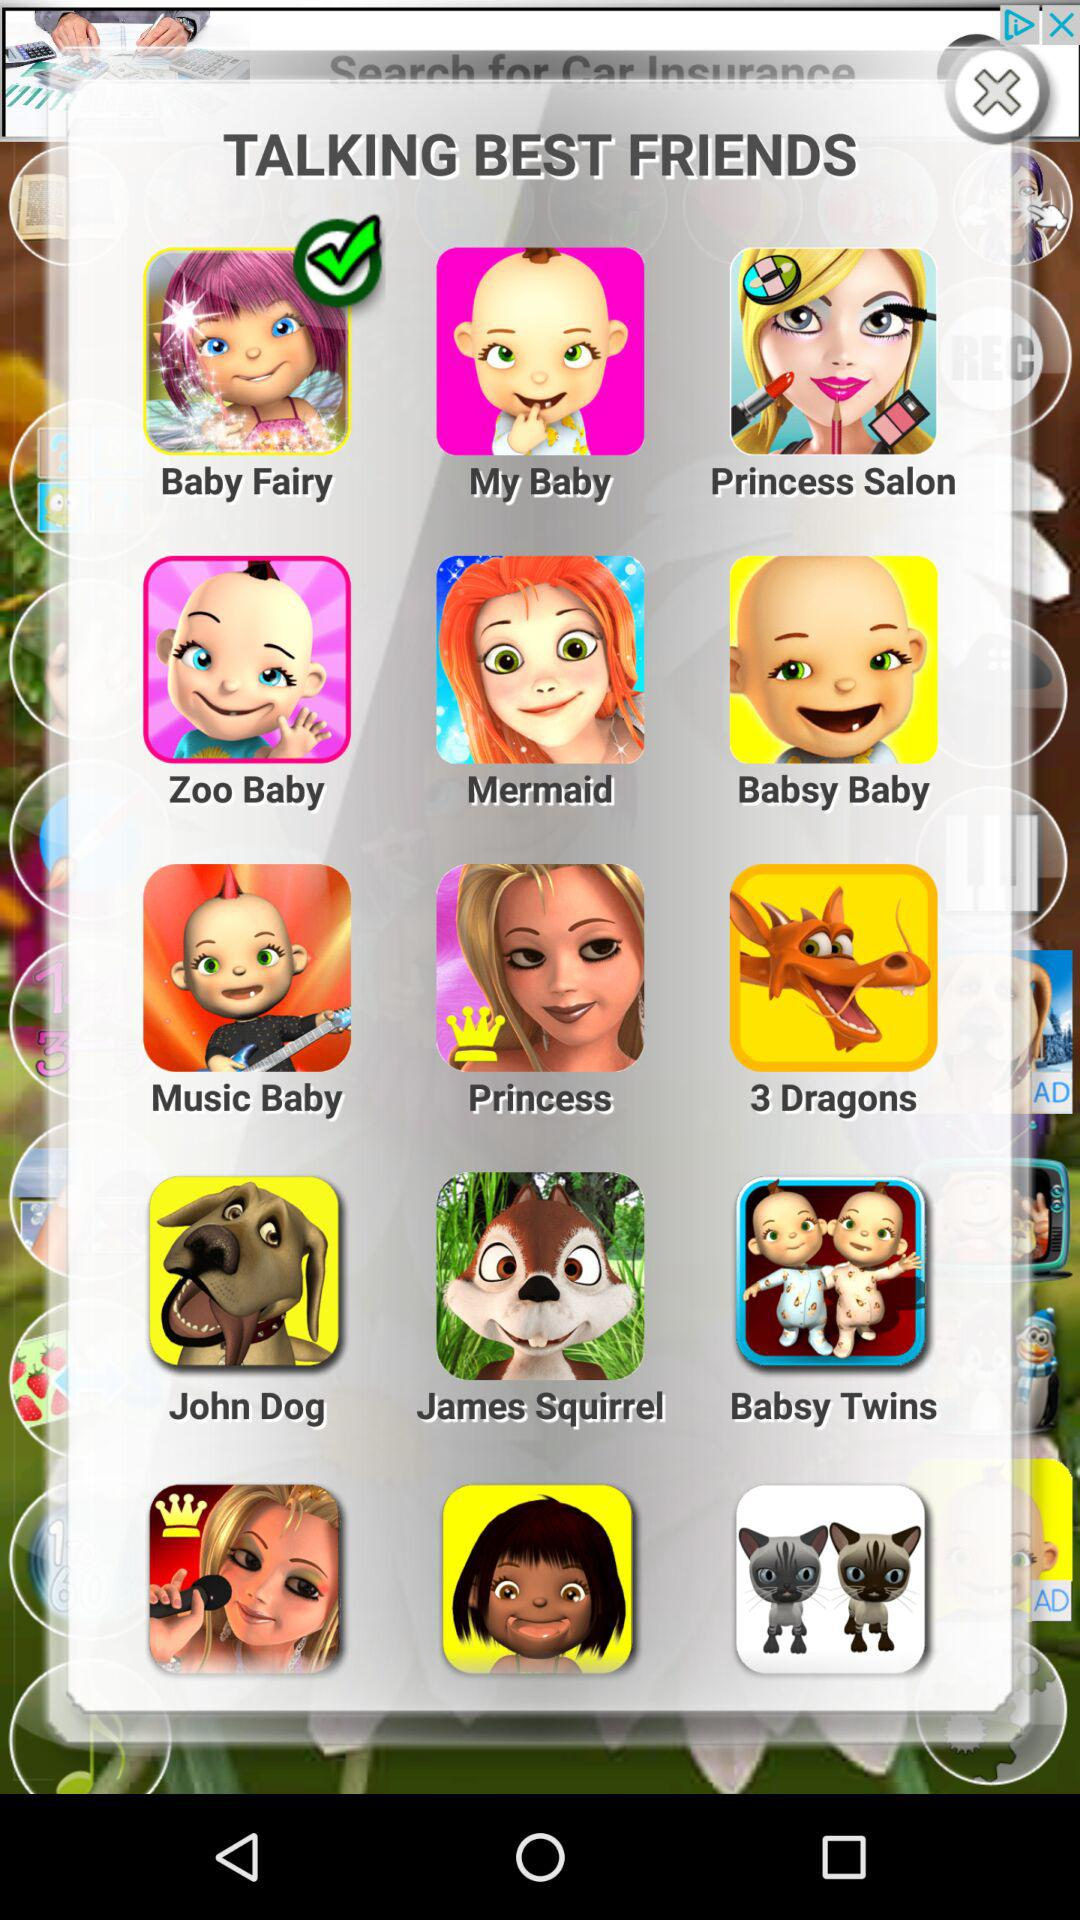Which option is selected for "TALKING BEST FRIENDS"? The selected option is "Baby Fairy". 